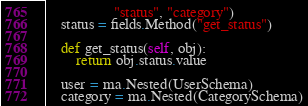<code> <loc_0><loc_0><loc_500><loc_500><_Python_>                  "status", "category")
    status = fields.Method("get_status")

    def get_status(self, obj):
        return obj.status.value

    user = ma.Nested(UserSchema)
    category = ma.Nested(CategorySchema)
</code> 